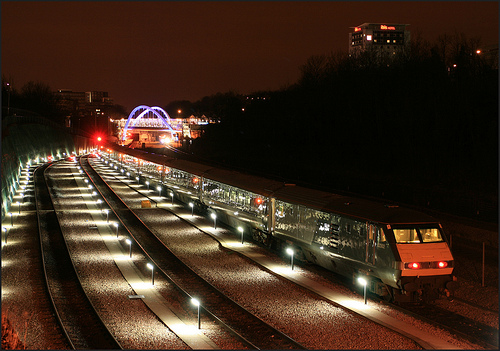How many tracks are shown? 3 